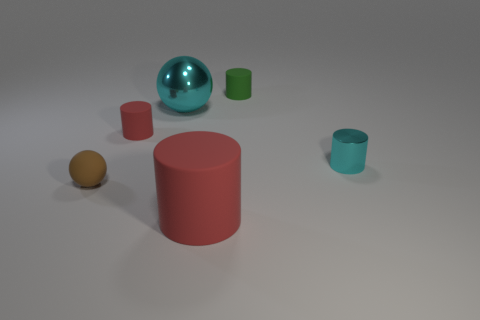There is a metal cylinder that is on the right side of the cyan object that is left of the cylinder right of the green rubber cylinder; what is its size?
Your answer should be compact. Small. How many other things are the same color as the tiny sphere?
Make the answer very short. 0. There is a cyan metal thing that is the same size as the brown sphere; what is its shape?
Your answer should be compact. Cylinder. How big is the matte cylinder that is left of the big matte cylinder?
Offer a terse response. Small. There is a big object behind the tiny red rubber cylinder; does it have the same color as the metallic object right of the big cyan thing?
Give a very brief answer. Yes. There is a small cylinder to the left of the red cylinder that is in front of the brown rubber ball that is in front of the big cyan ball; what is its material?
Ensure brevity in your answer.  Rubber. Is there a cyan metallic cylinder that has the same size as the cyan ball?
Your answer should be very brief. No. What material is the cylinder that is the same size as the metallic sphere?
Provide a succinct answer. Rubber. What shape is the big object that is behind the tiny brown sphere?
Make the answer very short. Sphere. Is the material of the cylinder that is on the right side of the small green cylinder the same as the large object that is behind the tiny sphere?
Ensure brevity in your answer.  Yes. 